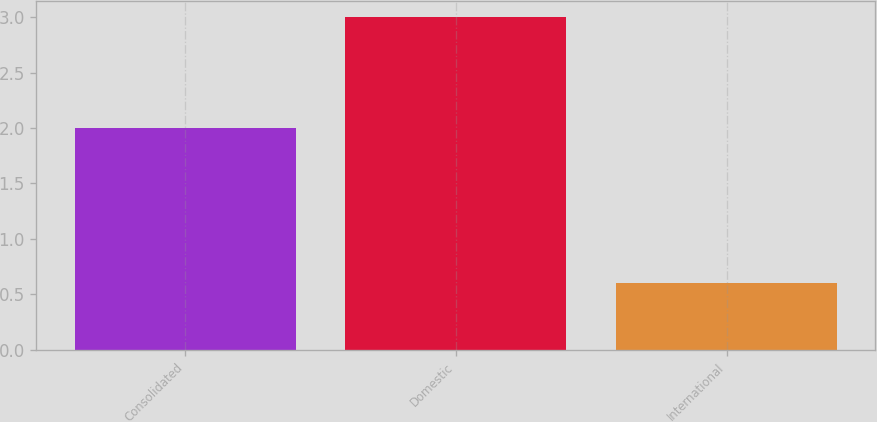<chart> <loc_0><loc_0><loc_500><loc_500><bar_chart><fcel>Consolidated<fcel>Domestic<fcel>International<nl><fcel>2<fcel>3<fcel>0.6<nl></chart> 